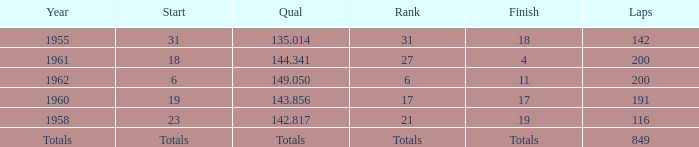What is the year with 116 laps? 1958.0. 